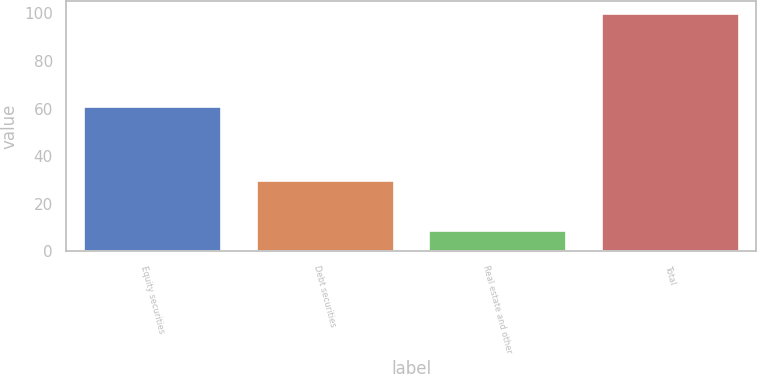Convert chart to OTSL. <chart><loc_0><loc_0><loc_500><loc_500><bar_chart><fcel>Equity securities<fcel>Debt securities<fcel>Real estate and other<fcel>Total<nl><fcel>61<fcel>30<fcel>9<fcel>100<nl></chart> 